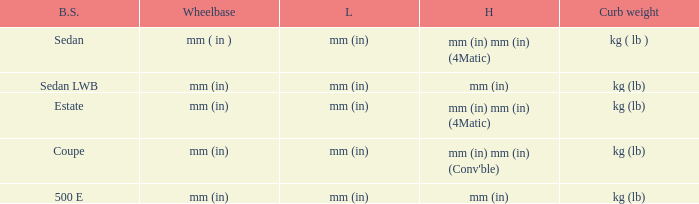What are the lengths of the models that are mm (in) tall? Mm (in), mm (in). 